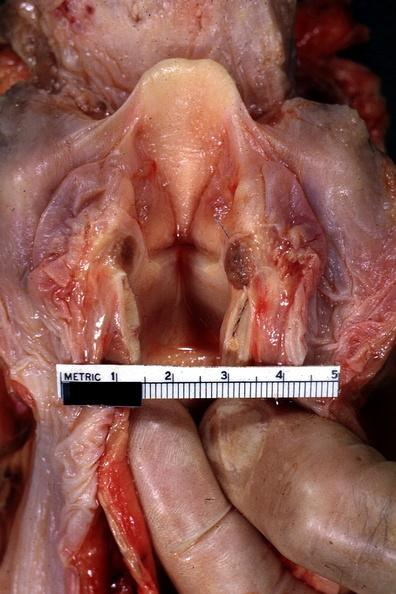what is present?
Answer the question using a single word or phrase. Oral 